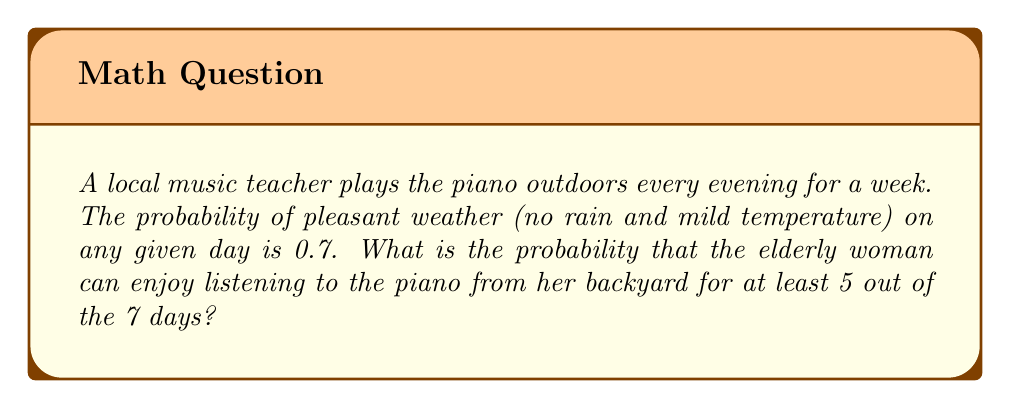Can you solve this math problem? Let's approach this step-by-step using the binomial probability distribution:

1) We can model this as a binomial experiment because:
   - There are a fixed number of trials (7 days)
   - Each trial has two possible outcomes (pleasant weather or not)
   - The probability of success (pleasant weather) is constant (0.7)
   - The trials are independent

2) We want the probability of at least 5 successes out of 7 trials. This means we need to calculate:
   P(X ≥ 5), where X is the number of days with pleasant weather

3) We can calculate this as:
   P(X ≥ 5) = P(X = 5) + P(X = 6) + P(X = 7)

4) The formula for binomial probability is:
   $$P(X = k) = \binom{n}{k} p^k (1-p)^{n-k}$$
   where n is the number of trials, k is the number of successes, and p is the probability of success

5) Let's calculate each term:

   For k = 5:
   $$P(X = 5) = \binom{7}{5} (0.7)^5 (0.3)^2 = 21 \cdot 0.16807 \cdot 0.09 = 0.3176$$

   For k = 6:
   $$P(X = 6) = \binom{7}{6} (0.7)^6 (0.3)^1 = 7 \cdot 0.117649 \cdot 0.3 = 0.2471$$

   For k = 7:
   $$P(X = 7) = \binom{7}{7} (0.7)^7 (0.3)^0 = 1 \cdot 0.0823543 \cdot 1 = 0.0824$$

6) Now, we sum these probabilities:
   P(X ≥ 5) = 0.3176 + 0.2471 + 0.0824 = 0.6471

Therefore, the probability of having at least 5 days of pleasant weather out of 7 is approximately 0.6471 or 64.71%.
Answer: 0.6471 